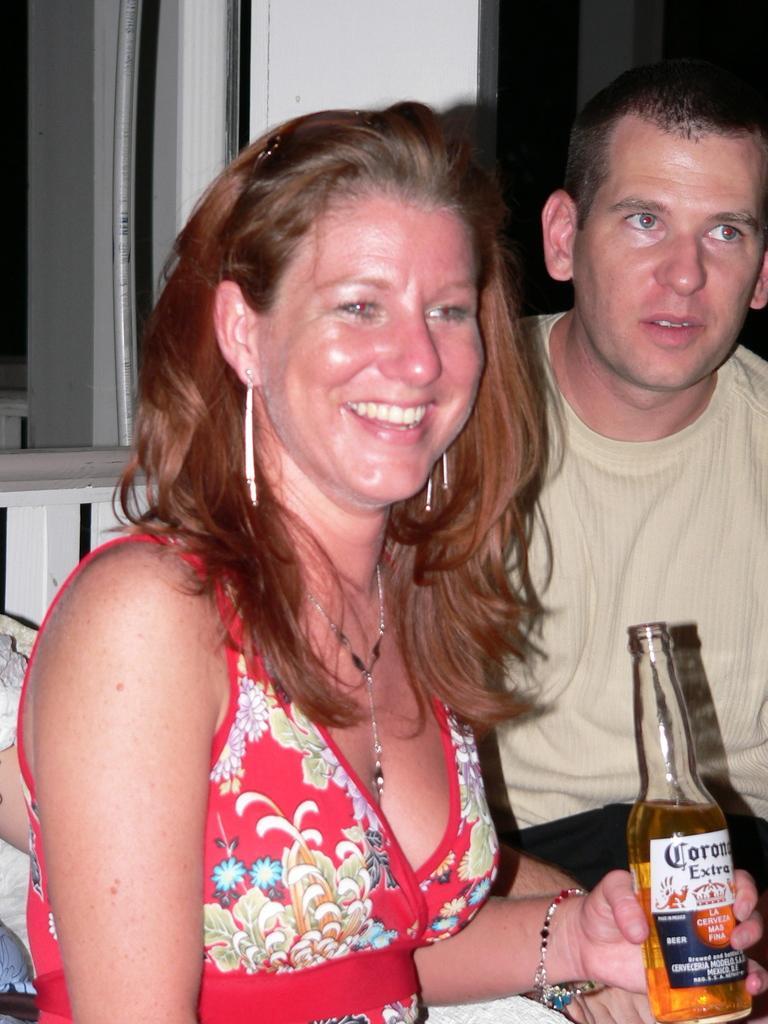How would you summarize this image in a sentence or two? In this image i can see a man and a woman, the woman is laughing and holding a bottle in her hand. At the background i can see a window. 